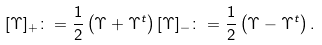Convert formula to latex. <formula><loc_0><loc_0><loc_500><loc_500>[ \Upsilon ] _ { + } \colon = \frac { 1 } { 2 } \left ( \Upsilon + \Upsilon ^ { t } \right ) [ \Upsilon ] _ { - } \colon = \frac { 1 } { 2 } \left ( \Upsilon - \Upsilon ^ { t } \right ) .</formula> 